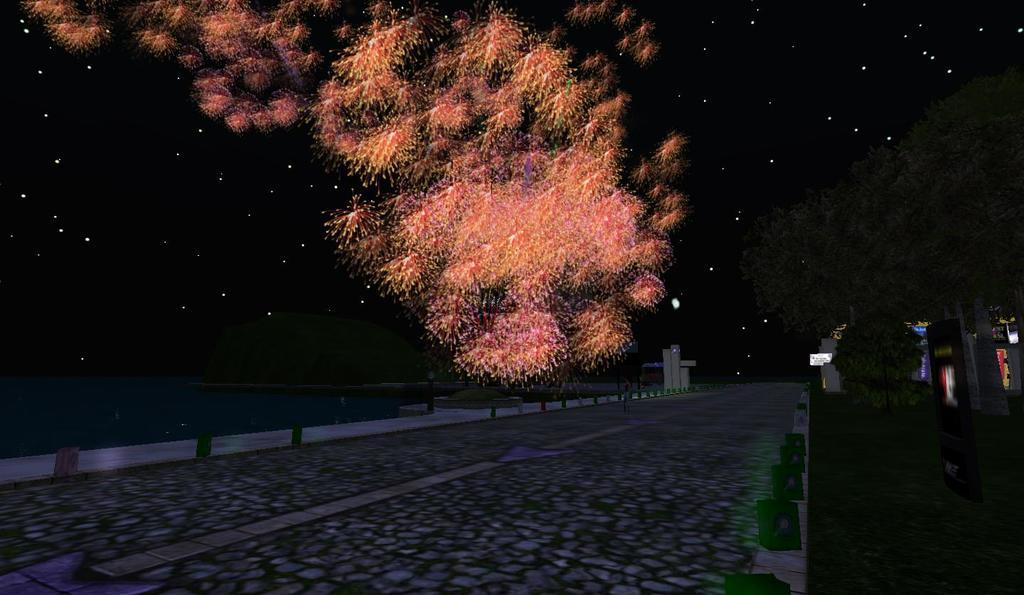What type of image is being described? The image is an animated picture. What can be seen on the ground in the image? There is a path in the image, as well as grass. Are there any plants visible in the image? Yes, there are trees in the image. What is the water element in the image? There is water in the image. What is visible in the background of the image? The sky is visible in the image, and it contains stars and sparkles. What time of day is depicted in the image? The image does not specify a time of day, so it cannot be determined whether it is afternoon or any other time. What type of canvas is used to create the image? The image is animated, so it is not created on a canvas. 